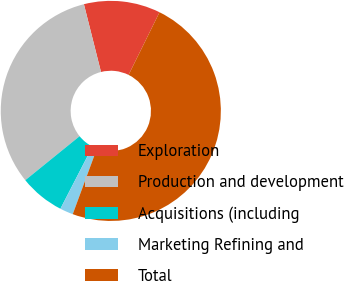Convert chart. <chart><loc_0><loc_0><loc_500><loc_500><pie_chart><fcel>Exploration<fcel>Production and development<fcel>Acquisitions (including<fcel>Marketing Refining and<fcel>Total<nl><fcel>11.23%<fcel>31.91%<fcel>6.59%<fcel>1.95%<fcel>48.32%<nl></chart> 